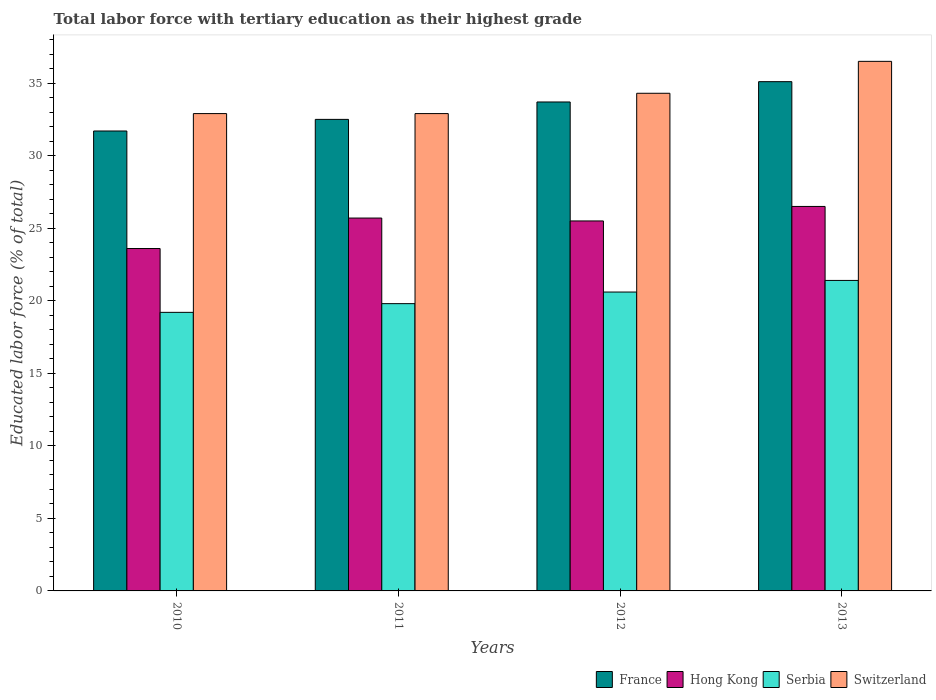How many groups of bars are there?
Your answer should be compact. 4. Are the number of bars per tick equal to the number of legend labels?
Provide a short and direct response. Yes. Are the number of bars on each tick of the X-axis equal?
Make the answer very short. Yes. How many bars are there on the 4th tick from the left?
Offer a very short reply. 4. What is the percentage of male labor force with tertiary education in Serbia in 2011?
Make the answer very short. 19.8. Across all years, what is the maximum percentage of male labor force with tertiary education in France?
Offer a very short reply. 35.1. Across all years, what is the minimum percentage of male labor force with tertiary education in Serbia?
Keep it short and to the point. 19.2. In which year was the percentage of male labor force with tertiary education in France minimum?
Make the answer very short. 2010. What is the total percentage of male labor force with tertiary education in France in the graph?
Give a very brief answer. 133. What is the difference between the percentage of male labor force with tertiary education in Switzerland in 2010 and that in 2013?
Keep it short and to the point. -3.6. What is the difference between the percentage of male labor force with tertiary education in France in 2010 and the percentage of male labor force with tertiary education in Switzerland in 2012?
Ensure brevity in your answer.  -2.6. What is the average percentage of male labor force with tertiary education in Hong Kong per year?
Ensure brevity in your answer.  25.33. In the year 2012, what is the difference between the percentage of male labor force with tertiary education in France and percentage of male labor force with tertiary education in Switzerland?
Ensure brevity in your answer.  -0.6. In how many years, is the percentage of male labor force with tertiary education in Switzerland greater than 36 %?
Keep it short and to the point. 1. What is the ratio of the percentage of male labor force with tertiary education in Switzerland in 2011 to that in 2012?
Give a very brief answer. 0.96. Is the difference between the percentage of male labor force with tertiary education in France in 2010 and 2011 greater than the difference between the percentage of male labor force with tertiary education in Switzerland in 2010 and 2011?
Ensure brevity in your answer.  No. What is the difference between the highest and the second highest percentage of male labor force with tertiary education in France?
Give a very brief answer. 1.4. What is the difference between the highest and the lowest percentage of male labor force with tertiary education in Switzerland?
Keep it short and to the point. 3.6. What does the 4th bar from the left in 2013 represents?
Provide a short and direct response. Switzerland. What does the 1st bar from the right in 2010 represents?
Make the answer very short. Switzerland. Is it the case that in every year, the sum of the percentage of male labor force with tertiary education in Switzerland and percentage of male labor force with tertiary education in Hong Kong is greater than the percentage of male labor force with tertiary education in Serbia?
Your answer should be compact. Yes. How many years are there in the graph?
Provide a succinct answer. 4. What is the difference between two consecutive major ticks on the Y-axis?
Keep it short and to the point. 5. Does the graph contain any zero values?
Offer a very short reply. No. How many legend labels are there?
Offer a very short reply. 4. How are the legend labels stacked?
Offer a very short reply. Horizontal. What is the title of the graph?
Ensure brevity in your answer.  Total labor force with tertiary education as their highest grade. What is the label or title of the X-axis?
Give a very brief answer. Years. What is the label or title of the Y-axis?
Your answer should be very brief. Educated labor force (% of total). What is the Educated labor force (% of total) of France in 2010?
Your response must be concise. 31.7. What is the Educated labor force (% of total) of Hong Kong in 2010?
Keep it short and to the point. 23.6. What is the Educated labor force (% of total) in Serbia in 2010?
Your answer should be compact. 19.2. What is the Educated labor force (% of total) of Switzerland in 2010?
Your answer should be compact. 32.9. What is the Educated labor force (% of total) of France in 2011?
Your answer should be compact. 32.5. What is the Educated labor force (% of total) of Hong Kong in 2011?
Ensure brevity in your answer.  25.7. What is the Educated labor force (% of total) of Serbia in 2011?
Give a very brief answer. 19.8. What is the Educated labor force (% of total) in Switzerland in 2011?
Provide a succinct answer. 32.9. What is the Educated labor force (% of total) of France in 2012?
Provide a short and direct response. 33.7. What is the Educated labor force (% of total) of Serbia in 2012?
Provide a succinct answer. 20.6. What is the Educated labor force (% of total) in Switzerland in 2012?
Keep it short and to the point. 34.3. What is the Educated labor force (% of total) in France in 2013?
Ensure brevity in your answer.  35.1. What is the Educated labor force (% of total) in Serbia in 2013?
Offer a very short reply. 21.4. What is the Educated labor force (% of total) of Switzerland in 2013?
Ensure brevity in your answer.  36.5. Across all years, what is the maximum Educated labor force (% of total) in France?
Provide a succinct answer. 35.1. Across all years, what is the maximum Educated labor force (% of total) of Hong Kong?
Provide a short and direct response. 26.5. Across all years, what is the maximum Educated labor force (% of total) of Serbia?
Make the answer very short. 21.4. Across all years, what is the maximum Educated labor force (% of total) in Switzerland?
Your answer should be compact. 36.5. Across all years, what is the minimum Educated labor force (% of total) in France?
Ensure brevity in your answer.  31.7. Across all years, what is the minimum Educated labor force (% of total) in Hong Kong?
Your answer should be compact. 23.6. Across all years, what is the minimum Educated labor force (% of total) of Serbia?
Provide a succinct answer. 19.2. Across all years, what is the minimum Educated labor force (% of total) of Switzerland?
Offer a very short reply. 32.9. What is the total Educated labor force (% of total) of France in the graph?
Offer a very short reply. 133. What is the total Educated labor force (% of total) of Hong Kong in the graph?
Your answer should be compact. 101.3. What is the total Educated labor force (% of total) of Serbia in the graph?
Your answer should be compact. 81. What is the total Educated labor force (% of total) of Switzerland in the graph?
Your answer should be compact. 136.6. What is the difference between the Educated labor force (% of total) in Hong Kong in 2010 and that in 2011?
Offer a terse response. -2.1. What is the difference between the Educated labor force (% of total) of Switzerland in 2010 and that in 2012?
Ensure brevity in your answer.  -1.4. What is the difference between the Educated labor force (% of total) of Hong Kong in 2010 and that in 2013?
Give a very brief answer. -2.9. What is the difference between the Educated labor force (% of total) of Switzerland in 2010 and that in 2013?
Give a very brief answer. -3.6. What is the difference between the Educated labor force (% of total) of France in 2011 and that in 2013?
Keep it short and to the point. -2.6. What is the difference between the Educated labor force (% of total) of France in 2012 and that in 2013?
Make the answer very short. -1.4. What is the difference between the Educated labor force (% of total) of Hong Kong in 2012 and that in 2013?
Keep it short and to the point. -1. What is the difference between the Educated labor force (% of total) of Serbia in 2012 and that in 2013?
Offer a very short reply. -0.8. What is the difference between the Educated labor force (% of total) of France in 2010 and the Educated labor force (% of total) of Hong Kong in 2011?
Offer a terse response. 6. What is the difference between the Educated labor force (% of total) of France in 2010 and the Educated labor force (% of total) of Serbia in 2011?
Offer a very short reply. 11.9. What is the difference between the Educated labor force (% of total) in Hong Kong in 2010 and the Educated labor force (% of total) in Serbia in 2011?
Your answer should be compact. 3.8. What is the difference between the Educated labor force (% of total) of Serbia in 2010 and the Educated labor force (% of total) of Switzerland in 2011?
Provide a succinct answer. -13.7. What is the difference between the Educated labor force (% of total) of France in 2010 and the Educated labor force (% of total) of Serbia in 2012?
Provide a succinct answer. 11.1. What is the difference between the Educated labor force (% of total) in France in 2010 and the Educated labor force (% of total) in Switzerland in 2012?
Your answer should be compact. -2.6. What is the difference between the Educated labor force (% of total) of Hong Kong in 2010 and the Educated labor force (% of total) of Switzerland in 2012?
Offer a terse response. -10.7. What is the difference between the Educated labor force (% of total) in Serbia in 2010 and the Educated labor force (% of total) in Switzerland in 2012?
Offer a very short reply. -15.1. What is the difference between the Educated labor force (% of total) in France in 2010 and the Educated labor force (% of total) in Hong Kong in 2013?
Give a very brief answer. 5.2. What is the difference between the Educated labor force (% of total) of France in 2010 and the Educated labor force (% of total) of Serbia in 2013?
Provide a short and direct response. 10.3. What is the difference between the Educated labor force (% of total) of France in 2010 and the Educated labor force (% of total) of Switzerland in 2013?
Ensure brevity in your answer.  -4.8. What is the difference between the Educated labor force (% of total) in Serbia in 2010 and the Educated labor force (% of total) in Switzerland in 2013?
Provide a short and direct response. -17.3. What is the difference between the Educated labor force (% of total) of France in 2011 and the Educated labor force (% of total) of Hong Kong in 2012?
Provide a succinct answer. 7. What is the difference between the Educated labor force (% of total) of France in 2011 and the Educated labor force (% of total) of Serbia in 2012?
Ensure brevity in your answer.  11.9. What is the difference between the Educated labor force (% of total) of France in 2011 and the Educated labor force (% of total) of Switzerland in 2012?
Your answer should be very brief. -1.8. What is the difference between the Educated labor force (% of total) of France in 2011 and the Educated labor force (% of total) of Switzerland in 2013?
Provide a short and direct response. -4. What is the difference between the Educated labor force (% of total) of Serbia in 2011 and the Educated labor force (% of total) of Switzerland in 2013?
Provide a succinct answer. -16.7. What is the difference between the Educated labor force (% of total) of France in 2012 and the Educated labor force (% of total) of Hong Kong in 2013?
Your answer should be compact. 7.2. What is the difference between the Educated labor force (% of total) in France in 2012 and the Educated labor force (% of total) in Serbia in 2013?
Your response must be concise. 12.3. What is the difference between the Educated labor force (% of total) of Hong Kong in 2012 and the Educated labor force (% of total) of Switzerland in 2013?
Your answer should be very brief. -11. What is the difference between the Educated labor force (% of total) of Serbia in 2012 and the Educated labor force (% of total) of Switzerland in 2013?
Provide a short and direct response. -15.9. What is the average Educated labor force (% of total) of France per year?
Offer a terse response. 33.25. What is the average Educated labor force (% of total) in Hong Kong per year?
Your response must be concise. 25.32. What is the average Educated labor force (% of total) in Serbia per year?
Your answer should be compact. 20.25. What is the average Educated labor force (% of total) of Switzerland per year?
Make the answer very short. 34.15. In the year 2010, what is the difference between the Educated labor force (% of total) in France and Educated labor force (% of total) in Serbia?
Your answer should be compact. 12.5. In the year 2010, what is the difference between the Educated labor force (% of total) in France and Educated labor force (% of total) in Switzerland?
Ensure brevity in your answer.  -1.2. In the year 2010, what is the difference between the Educated labor force (% of total) of Hong Kong and Educated labor force (% of total) of Switzerland?
Keep it short and to the point. -9.3. In the year 2010, what is the difference between the Educated labor force (% of total) of Serbia and Educated labor force (% of total) of Switzerland?
Provide a short and direct response. -13.7. In the year 2011, what is the difference between the Educated labor force (% of total) in France and Educated labor force (% of total) in Serbia?
Keep it short and to the point. 12.7. In the year 2012, what is the difference between the Educated labor force (% of total) in France and Educated labor force (% of total) in Switzerland?
Your answer should be very brief. -0.6. In the year 2012, what is the difference between the Educated labor force (% of total) of Hong Kong and Educated labor force (% of total) of Serbia?
Offer a very short reply. 4.9. In the year 2012, what is the difference between the Educated labor force (% of total) of Serbia and Educated labor force (% of total) of Switzerland?
Ensure brevity in your answer.  -13.7. In the year 2013, what is the difference between the Educated labor force (% of total) in France and Educated labor force (% of total) in Hong Kong?
Give a very brief answer. 8.6. In the year 2013, what is the difference between the Educated labor force (% of total) in France and Educated labor force (% of total) in Switzerland?
Keep it short and to the point. -1.4. In the year 2013, what is the difference between the Educated labor force (% of total) of Hong Kong and Educated labor force (% of total) of Switzerland?
Keep it short and to the point. -10. In the year 2013, what is the difference between the Educated labor force (% of total) of Serbia and Educated labor force (% of total) of Switzerland?
Offer a very short reply. -15.1. What is the ratio of the Educated labor force (% of total) of France in 2010 to that in 2011?
Offer a very short reply. 0.98. What is the ratio of the Educated labor force (% of total) of Hong Kong in 2010 to that in 2011?
Give a very brief answer. 0.92. What is the ratio of the Educated labor force (% of total) of Serbia in 2010 to that in 2011?
Ensure brevity in your answer.  0.97. What is the ratio of the Educated labor force (% of total) in France in 2010 to that in 2012?
Provide a short and direct response. 0.94. What is the ratio of the Educated labor force (% of total) of Hong Kong in 2010 to that in 2012?
Offer a terse response. 0.93. What is the ratio of the Educated labor force (% of total) in Serbia in 2010 to that in 2012?
Make the answer very short. 0.93. What is the ratio of the Educated labor force (% of total) in Switzerland in 2010 to that in 2012?
Offer a very short reply. 0.96. What is the ratio of the Educated labor force (% of total) in France in 2010 to that in 2013?
Give a very brief answer. 0.9. What is the ratio of the Educated labor force (% of total) in Hong Kong in 2010 to that in 2013?
Offer a very short reply. 0.89. What is the ratio of the Educated labor force (% of total) of Serbia in 2010 to that in 2013?
Make the answer very short. 0.9. What is the ratio of the Educated labor force (% of total) in Switzerland in 2010 to that in 2013?
Provide a short and direct response. 0.9. What is the ratio of the Educated labor force (% of total) of France in 2011 to that in 2012?
Your answer should be compact. 0.96. What is the ratio of the Educated labor force (% of total) of Hong Kong in 2011 to that in 2012?
Give a very brief answer. 1.01. What is the ratio of the Educated labor force (% of total) of Serbia in 2011 to that in 2012?
Your answer should be very brief. 0.96. What is the ratio of the Educated labor force (% of total) in Switzerland in 2011 to that in 2012?
Offer a terse response. 0.96. What is the ratio of the Educated labor force (% of total) in France in 2011 to that in 2013?
Offer a terse response. 0.93. What is the ratio of the Educated labor force (% of total) in Hong Kong in 2011 to that in 2013?
Give a very brief answer. 0.97. What is the ratio of the Educated labor force (% of total) of Serbia in 2011 to that in 2013?
Provide a short and direct response. 0.93. What is the ratio of the Educated labor force (% of total) of Switzerland in 2011 to that in 2013?
Keep it short and to the point. 0.9. What is the ratio of the Educated labor force (% of total) in France in 2012 to that in 2013?
Offer a very short reply. 0.96. What is the ratio of the Educated labor force (% of total) in Hong Kong in 2012 to that in 2013?
Provide a succinct answer. 0.96. What is the ratio of the Educated labor force (% of total) of Serbia in 2012 to that in 2013?
Make the answer very short. 0.96. What is the ratio of the Educated labor force (% of total) in Switzerland in 2012 to that in 2013?
Your response must be concise. 0.94. What is the difference between the highest and the second highest Educated labor force (% of total) in Hong Kong?
Provide a short and direct response. 0.8. What is the difference between the highest and the second highest Educated labor force (% of total) in Serbia?
Keep it short and to the point. 0.8. What is the difference between the highest and the second highest Educated labor force (% of total) in Switzerland?
Give a very brief answer. 2.2. What is the difference between the highest and the lowest Educated labor force (% of total) in France?
Provide a short and direct response. 3.4. 